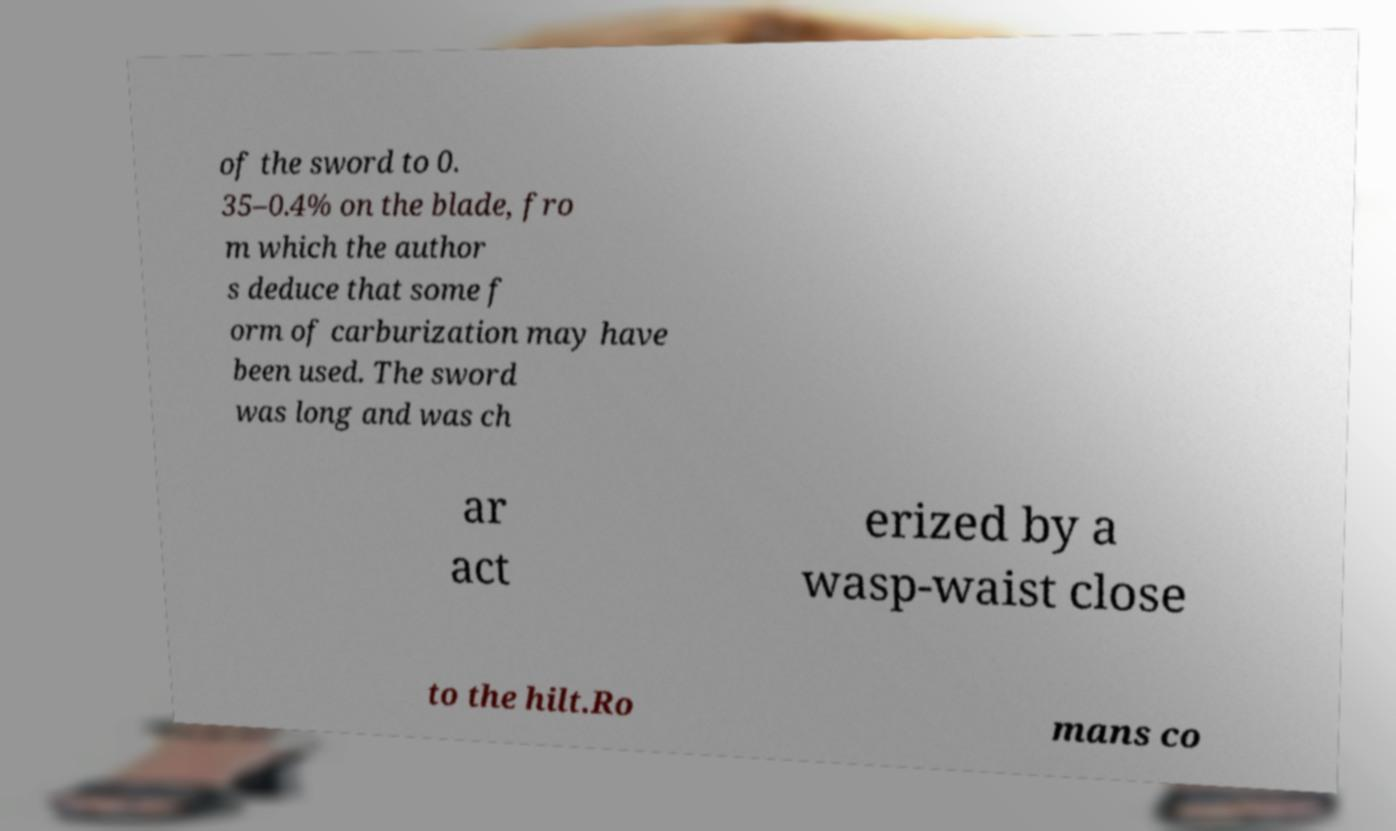Can you read and provide the text displayed in the image?This photo seems to have some interesting text. Can you extract and type it out for me? of the sword to 0. 35–0.4% on the blade, fro m which the author s deduce that some f orm of carburization may have been used. The sword was long and was ch ar act erized by a wasp-waist close to the hilt.Ro mans co 